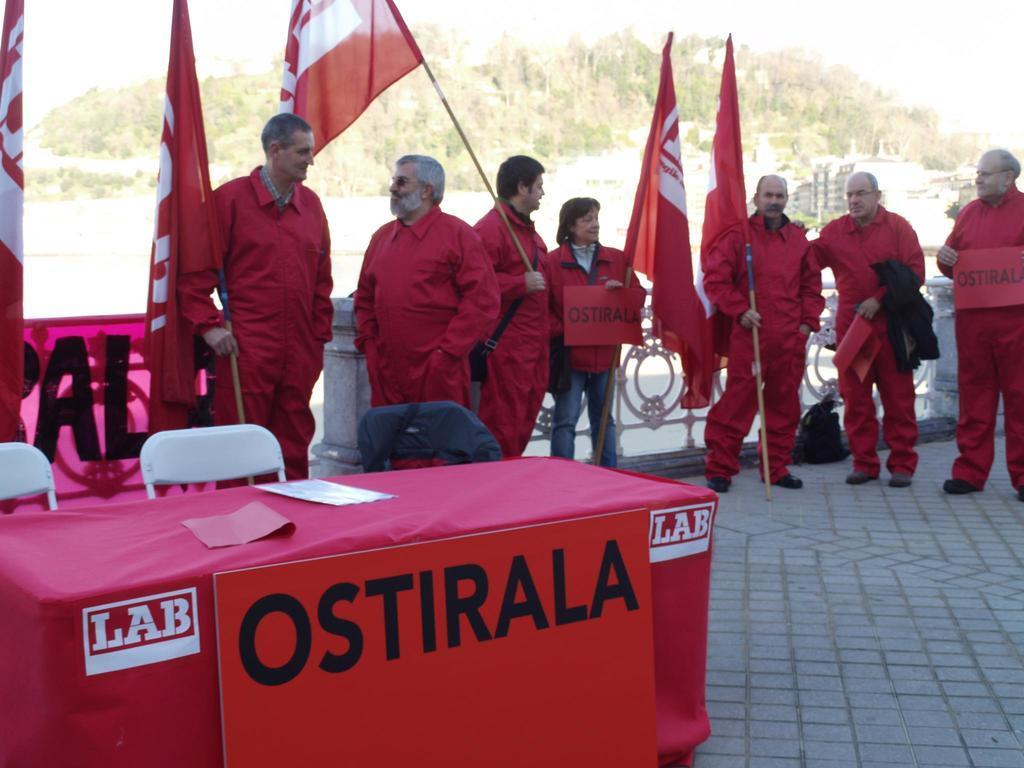Describe this image in one or two sentences. In this image there are few persons wearing red color dress and holding flags in there hands, in the left side there is a table and chairs, in the background there are trees. 